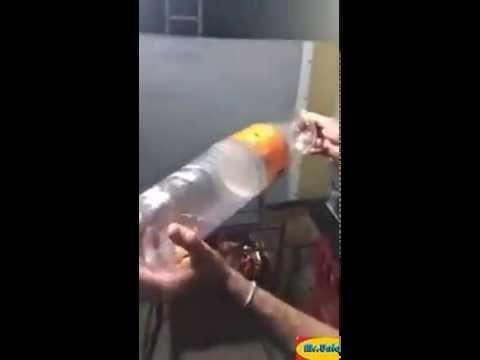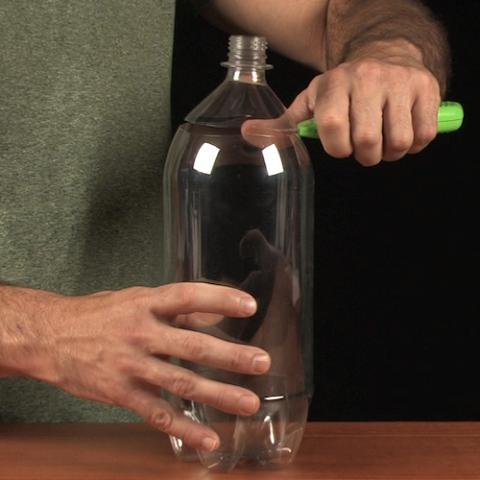The first image is the image on the left, the second image is the image on the right. Assess this claim about the two images: "There is at least one  twisted  or crushed soda bottle". Correct or not? Answer yes or no. No. The first image is the image on the left, the second image is the image on the right. Given the left and right images, does the statement "There are at least two hands." hold true? Answer yes or no. Yes. 